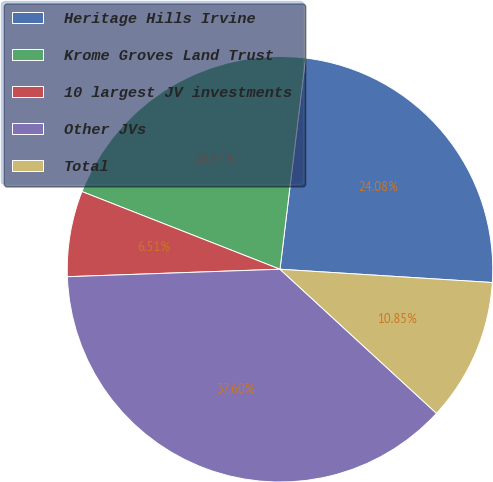Convert chart to OTSL. <chart><loc_0><loc_0><loc_500><loc_500><pie_chart><fcel>Heritage Hills Irvine<fcel>Krome Groves Land Trust<fcel>10 largest JV investments<fcel>Other JVs<fcel>Total<nl><fcel>24.08%<fcel>20.97%<fcel>6.51%<fcel>37.6%<fcel>10.85%<nl></chart> 